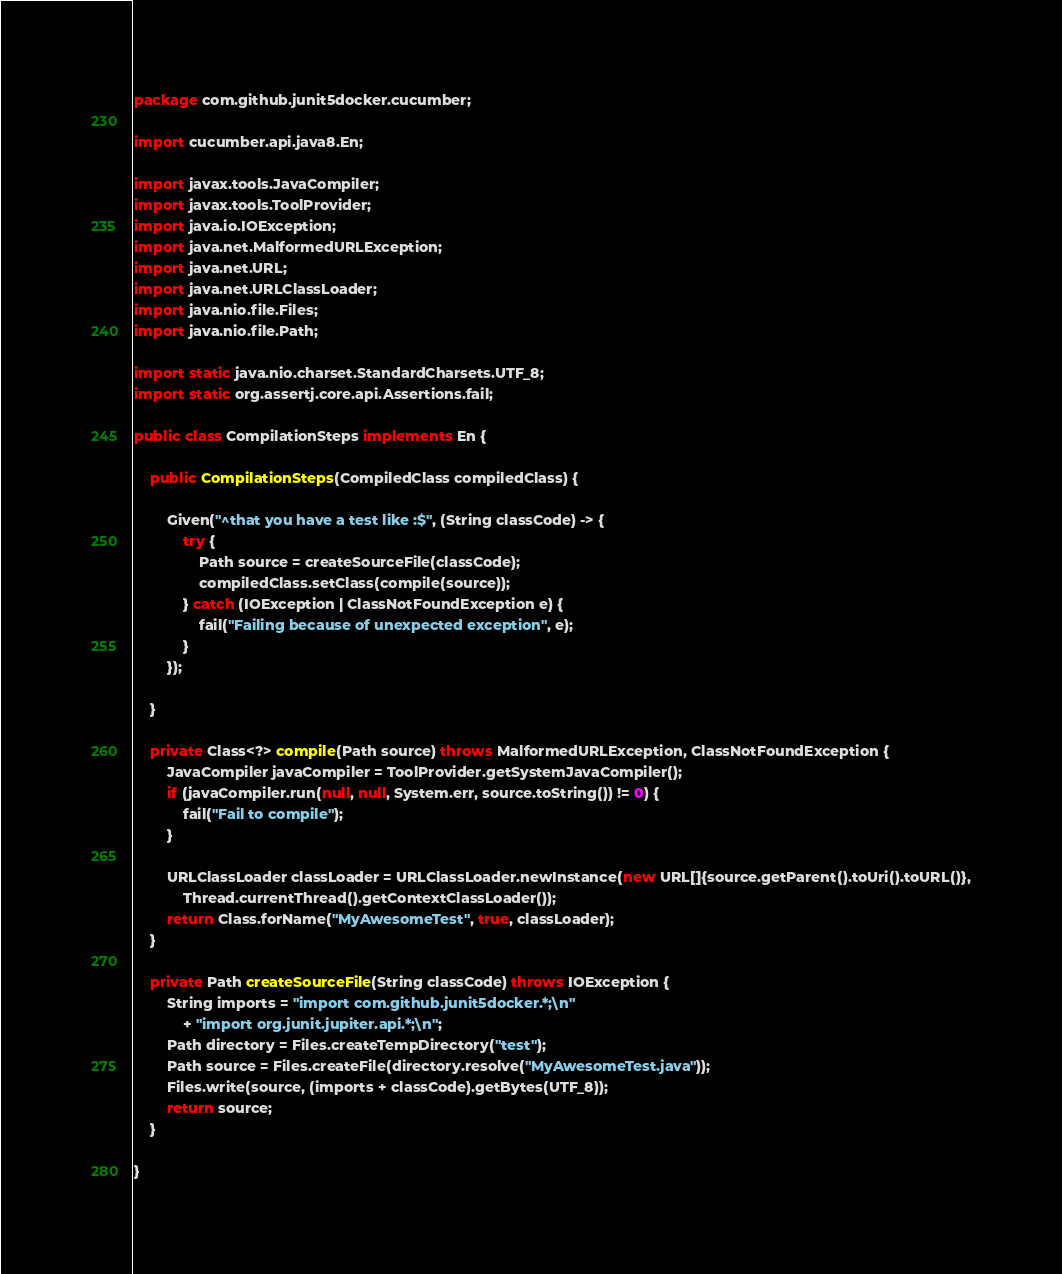<code> <loc_0><loc_0><loc_500><loc_500><_Java_>package com.github.junit5docker.cucumber;

import cucumber.api.java8.En;

import javax.tools.JavaCompiler;
import javax.tools.ToolProvider;
import java.io.IOException;
import java.net.MalformedURLException;
import java.net.URL;
import java.net.URLClassLoader;
import java.nio.file.Files;
import java.nio.file.Path;

import static java.nio.charset.StandardCharsets.UTF_8;
import static org.assertj.core.api.Assertions.fail;

public class CompilationSteps implements En {

    public CompilationSteps(CompiledClass compiledClass) {

        Given("^that you have a test like :$", (String classCode) -> {
            try {
                Path source = createSourceFile(classCode);
                compiledClass.setClass(compile(source));
            } catch (IOException | ClassNotFoundException e) {
                fail("Failing because of unexpected exception", e);
            }
        });

    }

    private Class<?> compile(Path source) throws MalformedURLException, ClassNotFoundException {
        JavaCompiler javaCompiler = ToolProvider.getSystemJavaCompiler();
        if (javaCompiler.run(null, null, System.err, source.toString()) != 0) {
            fail("Fail to compile");
        }

        URLClassLoader classLoader = URLClassLoader.newInstance(new URL[]{source.getParent().toUri().toURL()},
            Thread.currentThread().getContextClassLoader());
        return Class.forName("MyAwesomeTest", true, classLoader);
    }

    private Path createSourceFile(String classCode) throws IOException {
        String imports = "import com.github.junit5docker.*;\n"
            + "import org.junit.jupiter.api.*;\n";
        Path directory = Files.createTempDirectory("test");
        Path source = Files.createFile(directory.resolve("MyAwesomeTest.java"));
        Files.write(source, (imports + classCode).getBytes(UTF_8));
        return source;
    }

}
</code> 